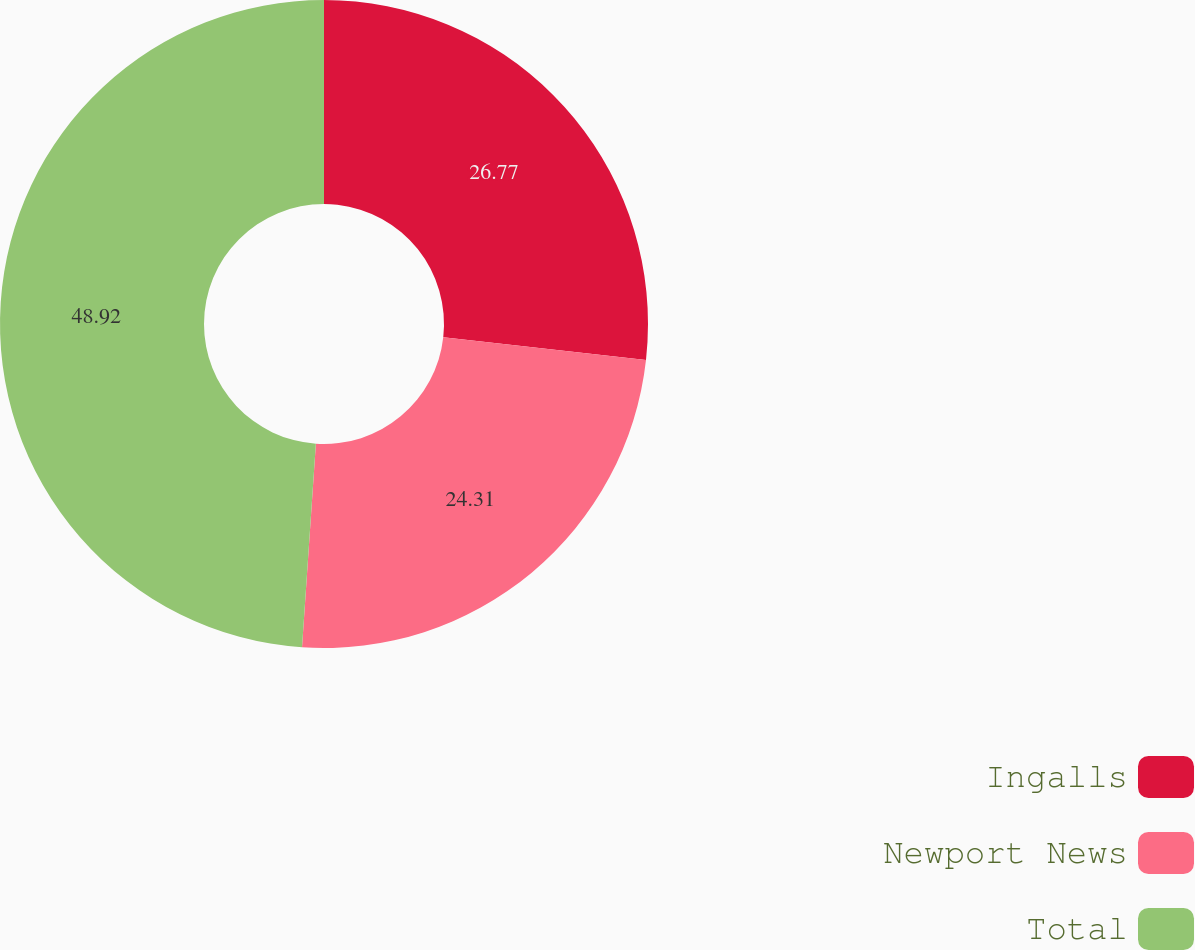Convert chart. <chart><loc_0><loc_0><loc_500><loc_500><pie_chart><fcel>Ingalls<fcel>Newport News<fcel>Total<nl><fcel>26.77%<fcel>24.31%<fcel>48.92%<nl></chart> 